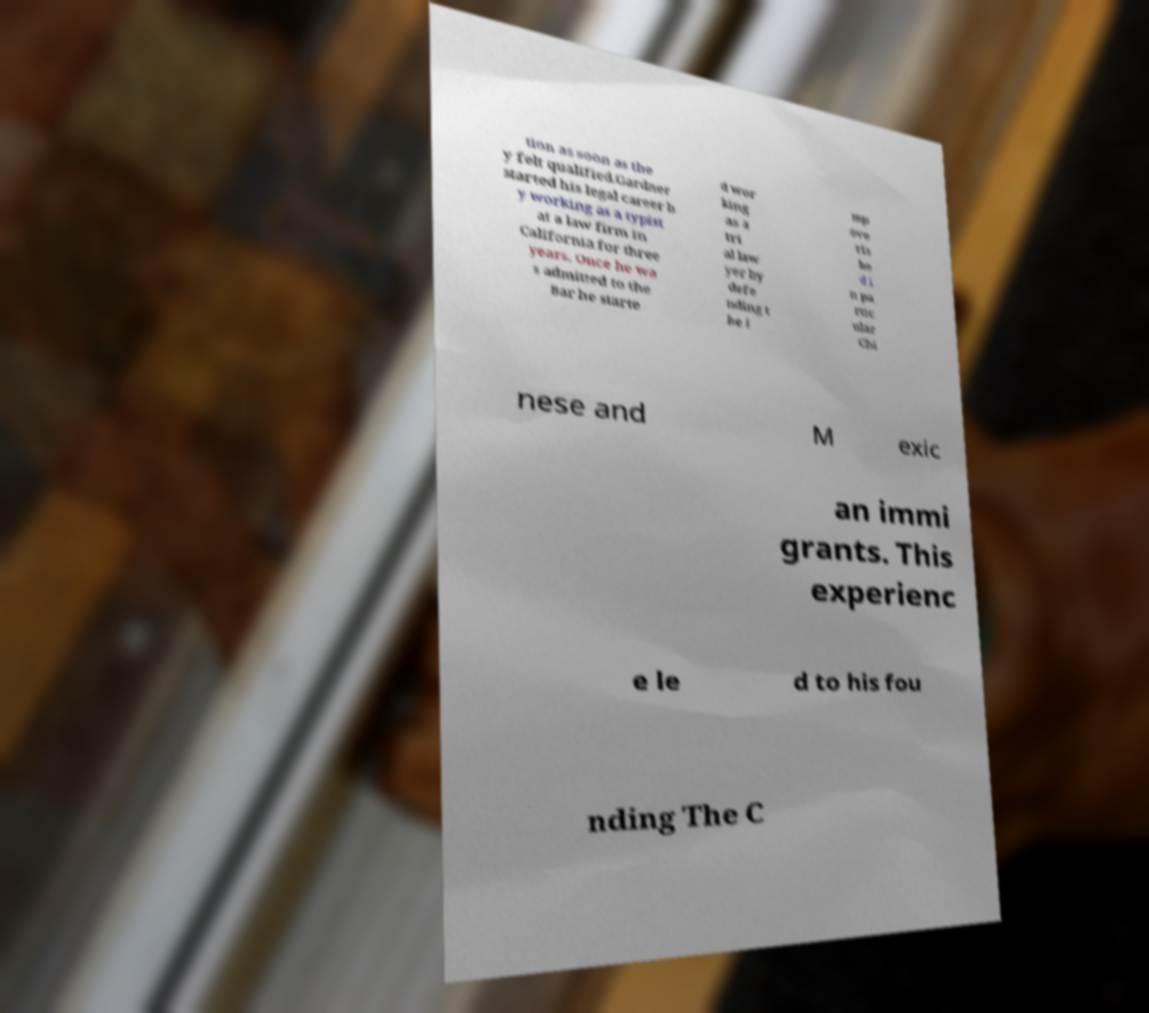Please identify and transcribe the text found in this image. tion as soon as the y felt qualified.Gardner started his legal career b y working as a typist at a law firm in California for three years. Once he wa s admitted to the Bar he starte d wor king as a tri al law yer by defe nding t he i mp ove ris he d i n pa rtic ular Chi nese and M exic an immi grants. This experienc e le d to his fou nding The C 